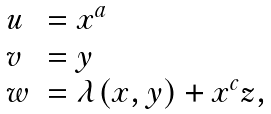Convert formula to latex. <formula><loc_0><loc_0><loc_500><loc_500>\begin{array} { l l } u & = x ^ { a } \\ v & = y \\ w & = \lambda ( x , y ) + x ^ { c } z , \end{array}</formula> 